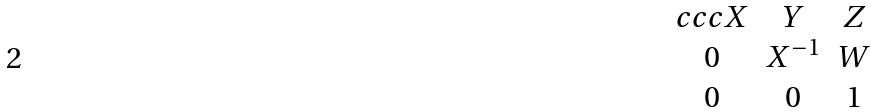Convert formula to latex. <formula><loc_0><loc_0><loc_500><loc_500>\begin{matrix} { c c c } X & Y & Z \\ 0 & X ^ { - 1 } & W \\ 0 & 0 & 1 \end{matrix}</formula> 